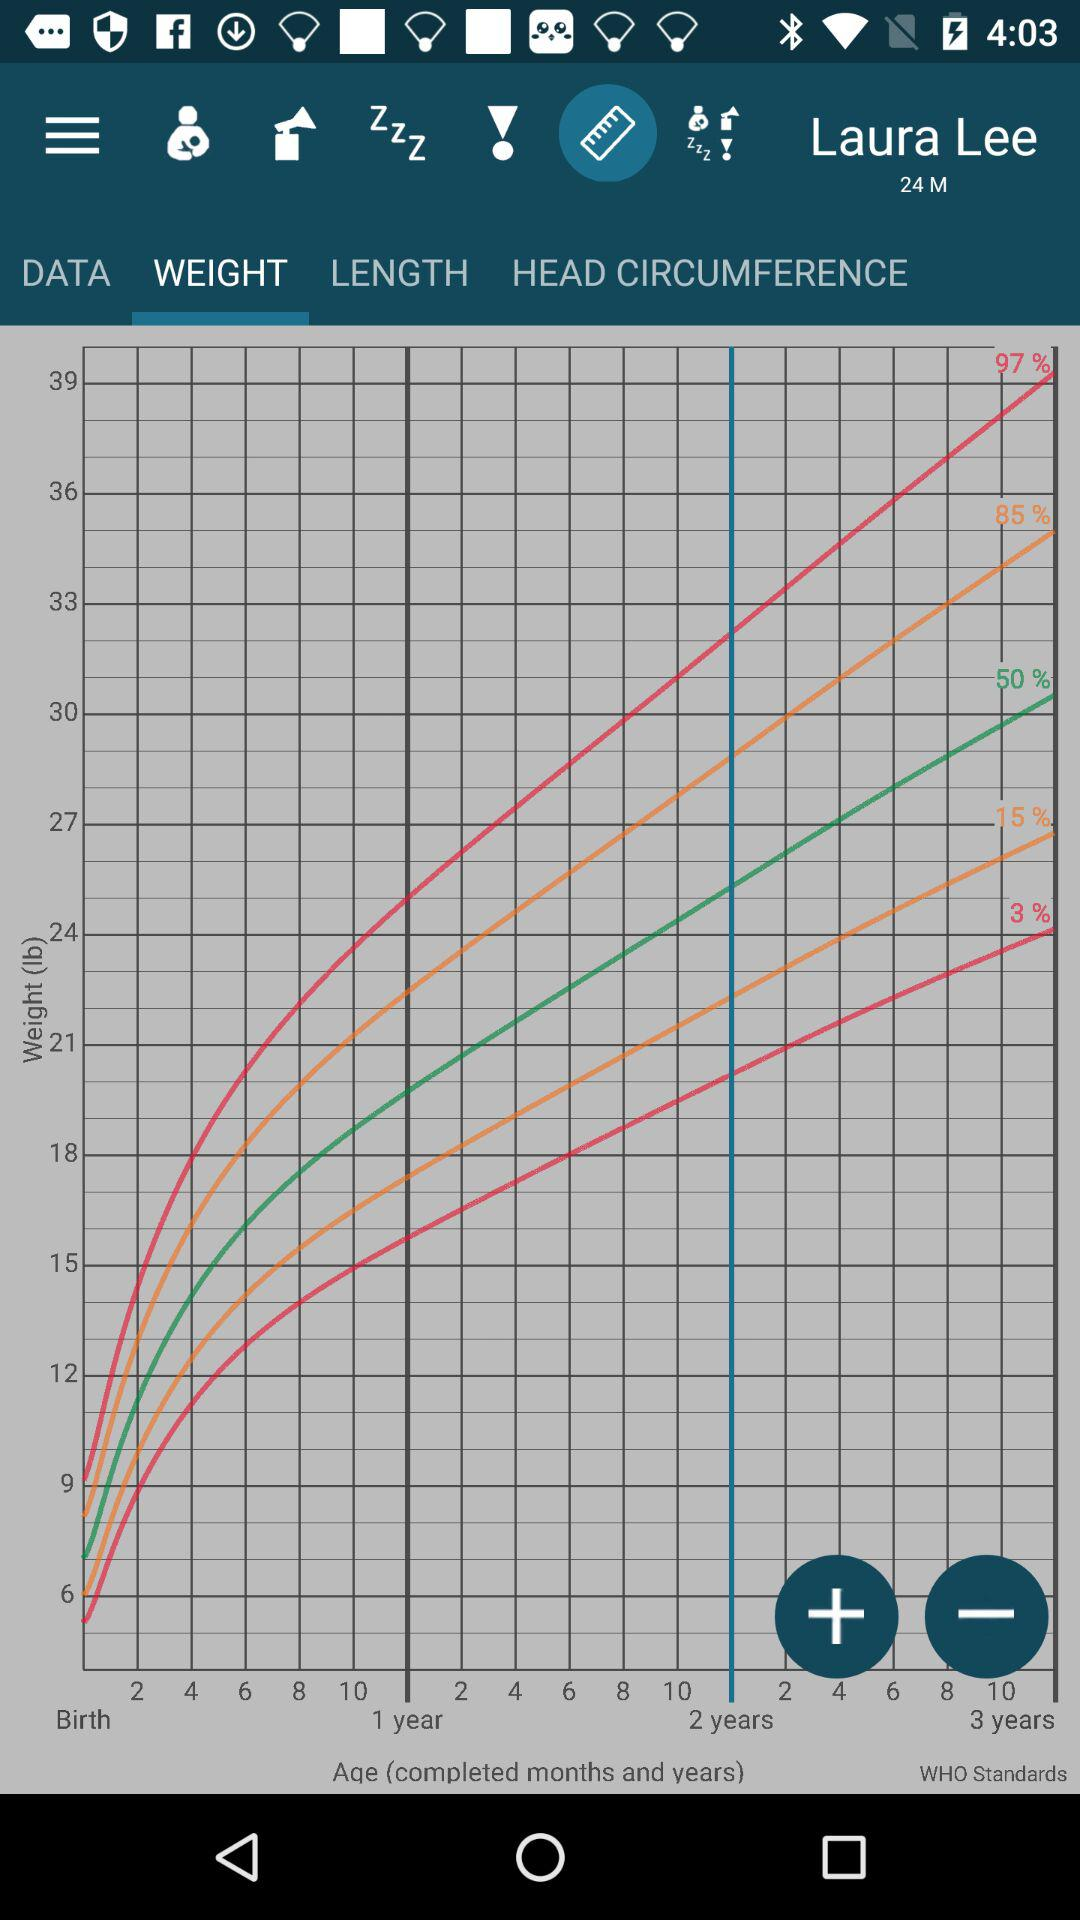Which chart is being shown right now? It is the "WEIGHT" chart that is being shown right now. 